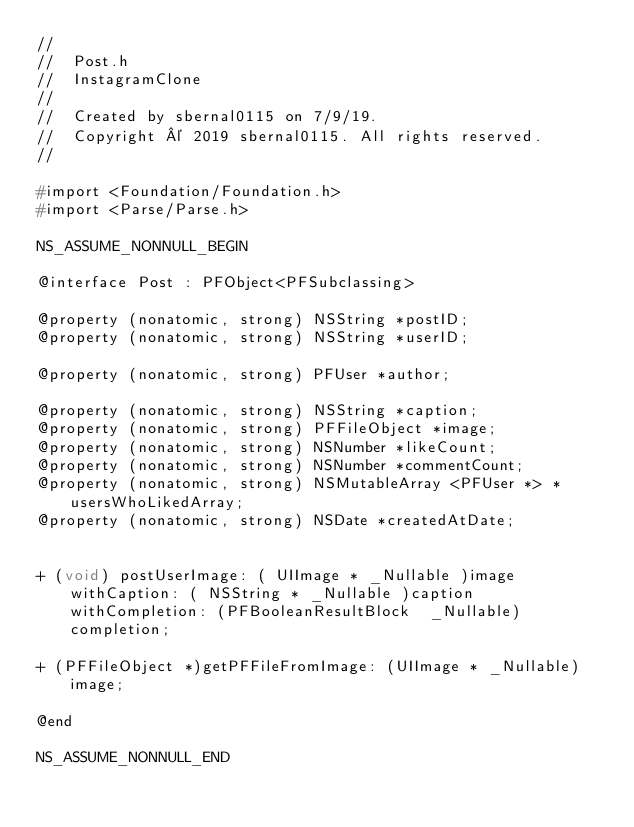<code> <loc_0><loc_0><loc_500><loc_500><_C_>//
//  Post.h
//  InstagramClone
//
//  Created by sbernal0115 on 7/9/19.
//  Copyright © 2019 sbernal0115. All rights reserved.
//

#import <Foundation/Foundation.h>
#import <Parse/Parse.h>

NS_ASSUME_NONNULL_BEGIN

@interface Post : PFObject<PFSubclassing>

@property (nonatomic, strong) NSString *postID;
@property (nonatomic, strong) NSString *userID;

@property (nonatomic, strong) PFUser *author;

@property (nonatomic, strong) NSString *caption;
@property (nonatomic, strong) PFFileObject *image;
@property (nonatomic, strong) NSNumber *likeCount;
@property (nonatomic, strong) NSNumber *commentCount;
@property (nonatomic, strong) NSMutableArray <PFUser *> *usersWhoLikedArray;
@property (nonatomic, strong) NSDate *createdAtDate;


+ (void) postUserImage: ( UIImage * _Nullable )image withCaption: ( NSString * _Nullable )caption withCompletion: (PFBooleanResultBlock  _Nullable)completion;

+ (PFFileObject *)getPFFileFromImage: (UIImage * _Nullable)image;

@end

NS_ASSUME_NONNULL_END
</code> 